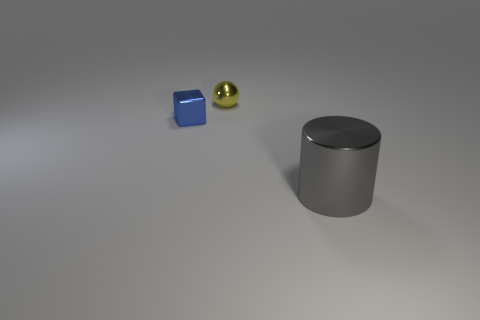Does the cube have the same size as the yellow shiny ball?
Give a very brief answer. Yes. What color is the shiny object that is both in front of the ball and on the right side of the small metallic block?
Keep it short and to the point. Gray. What is the small thing that is to the right of the metallic object that is to the left of the yellow shiny sphere made of?
Your answer should be compact. Metal. There is a metal thing on the left side of the tiny yellow metallic ball; is its color the same as the cylinder?
Make the answer very short. No. Are there fewer tiny metallic spheres than tiny cyan shiny balls?
Your response must be concise. No. Are the object in front of the blue metallic block and the small yellow sphere made of the same material?
Provide a succinct answer. Yes. There is a tiny thing behind the blue object; what is it made of?
Provide a short and direct response. Metal. What size is the object to the left of the small metal thing that is to the right of the blue shiny cube?
Keep it short and to the point. Small. Is there a yellow ball that has the same material as the cylinder?
Give a very brief answer. Yes. There is a thing behind the object that is on the left side of the shiny object behind the blue thing; what is its shape?
Offer a terse response. Sphere. 